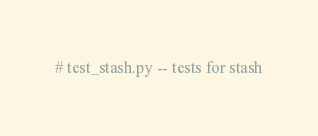<code> <loc_0><loc_0><loc_500><loc_500><_Python_># test_stash.py -- tests for stash</code> 